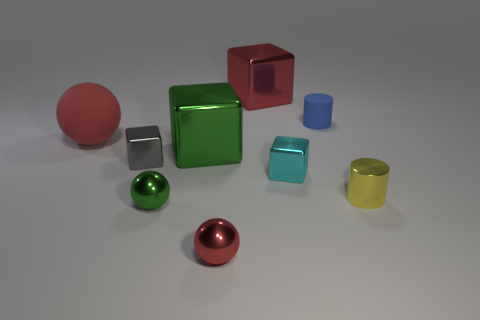Add 1 tiny yellow rubber cylinders. How many objects exist? 10 Subtract all cylinders. How many objects are left? 7 Add 6 small cylinders. How many small cylinders exist? 8 Subtract 0 gray cylinders. How many objects are left? 9 Subtract all rubber objects. Subtract all blue cylinders. How many objects are left? 6 Add 2 large red things. How many large red things are left? 4 